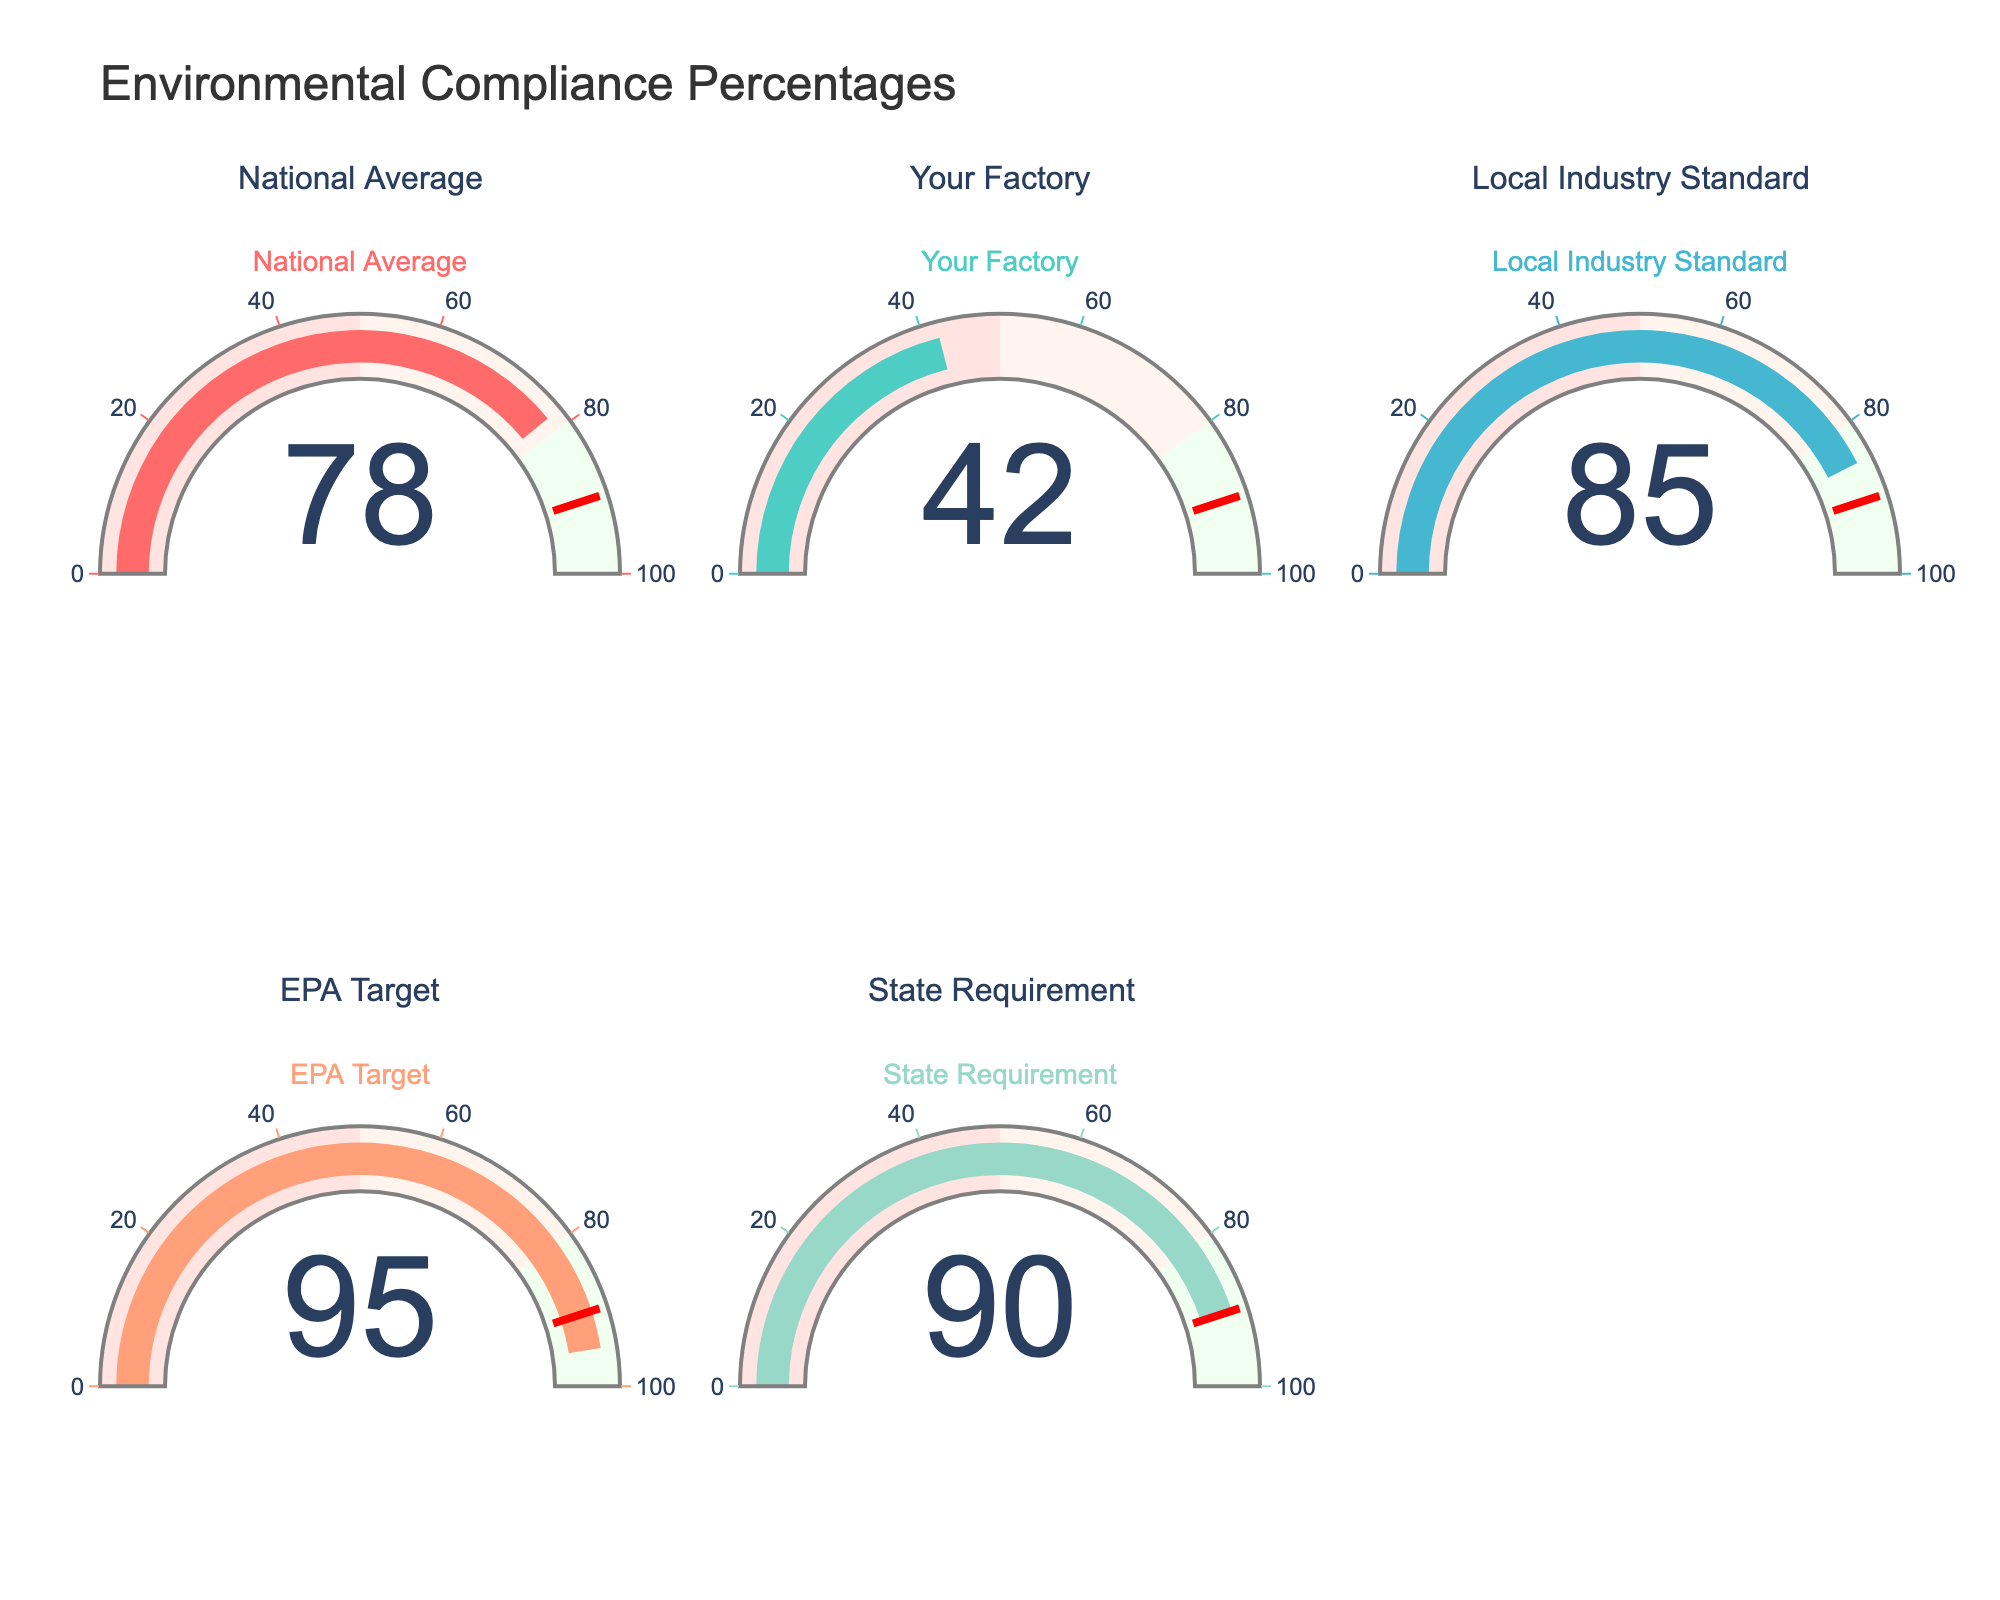What is the compliance percentage for your factory? Locate the gauge labeled "Your Factory." The number displayed shows the compliance percentage.
Answer: 42 Which facility has the highest compliance percentage? Compare the percentages shown on all the gauges and identify the highest value.
Answer: EPA Target What is the median compliance percentage among all the facilities shown? List the compliance percentages: 42, 78, 85, 90, 95. Order them to find the middle value. The median is 85.
Answer: 85 How much higher is the state requirement than your factory's compliance percentage? Subtract the compliance percentage of "Your Factory" from "State Requirement": 90 - 42 = 48
Answer: 48 Is the compliance percentage of your factory above or below the national average? Compare the compliance percentage of "Your Factory" (42) with "National Average" (78). 42 is below 78.
Answer: Below Which facilities exceed the EPA target? Compare each facility's compliance percentage with the EPA Target (95). None exceed 95.
Answer: None What are the visual indicators of the compliance percentages on the gauges? Notice the bars and their colors on each gauge representing the compliance percentages. Red indicates a low range, and green indicates a high range.
Answer: Colored bars (red to green) What is the difference in compliance percentage between the local industry standard and the national average? Subtract the compliance percentage of "National Average" from "Local Industry Standard": 85 - 78 = 7
Answer: 7 If the compliance percentage of your factory improved by 10%, what would the new compliance percentage be? Add 10 to the current percentage of "Your Factory": 42 + 10 = 52
Answer: 52 